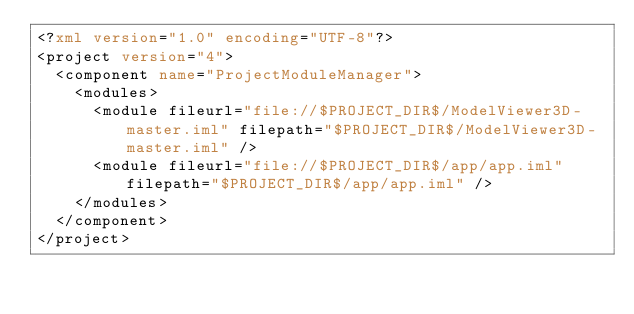Convert code to text. <code><loc_0><loc_0><loc_500><loc_500><_XML_><?xml version="1.0" encoding="UTF-8"?>
<project version="4">
  <component name="ProjectModuleManager">
    <modules>
      <module fileurl="file://$PROJECT_DIR$/ModelViewer3D-master.iml" filepath="$PROJECT_DIR$/ModelViewer3D-master.iml" />
      <module fileurl="file://$PROJECT_DIR$/app/app.iml" filepath="$PROJECT_DIR$/app/app.iml" />
    </modules>
  </component>
</project></code> 